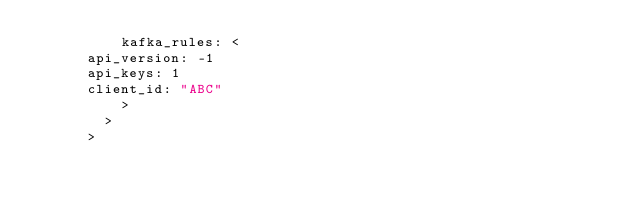Convert code to text. <code><loc_0><loc_0><loc_500><loc_500><_Go_>		      kafka_rules: <
			api_version: -1
			api_keys: 1
			client_id: "ABC"
		      >
		    >
		  ></code> 